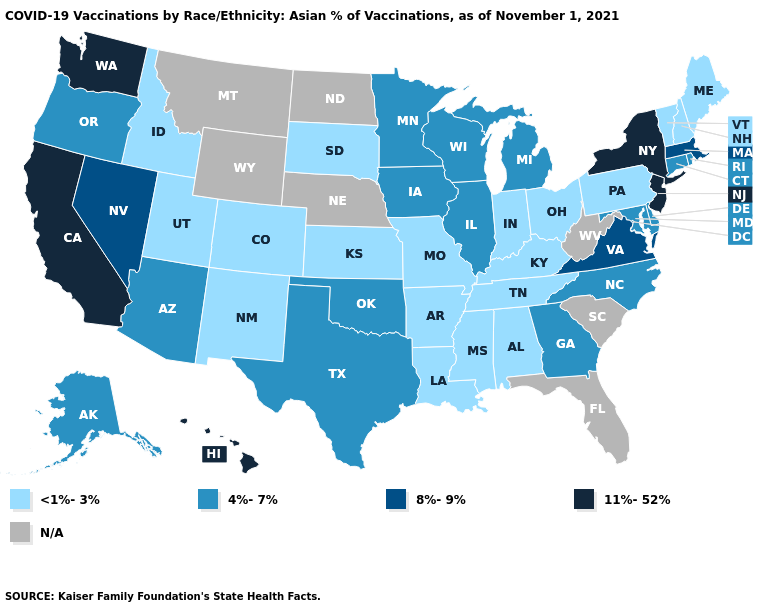Which states have the lowest value in the MidWest?
Quick response, please. Indiana, Kansas, Missouri, Ohio, South Dakota. Does the first symbol in the legend represent the smallest category?
Answer briefly. Yes. What is the value of Arizona?
Quick response, please. 4%-7%. What is the highest value in states that border New Mexico?
Concise answer only. 4%-7%. Does Hawaii have the highest value in the USA?
Concise answer only. Yes. What is the value of Louisiana?
Keep it brief. <1%-3%. What is the highest value in the USA?
Give a very brief answer. 11%-52%. What is the value of Delaware?
Be succinct. 4%-7%. Does the first symbol in the legend represent the smallest category?
Give a very brief answer. Yes. Among the states that border Texas , which have the lowest value?
Give a very brief answer. Arkansas, Louisiana, New Mexico. What is the value of Texas?
Be succinct. 4%-7%. What is the value of Colorado?
Answer briefly. <1%-3%. Is the legend a continuous bar?
Keep it brief. No. What is the value of Minnesota?
Write a very short answer. 4%-7%. 